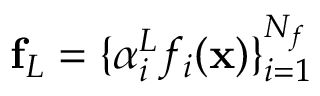<formula> <loc_0><loc_0><loc_500><loc_500>f _ { L } = \{ \alpha _ { i } ^ { L } f _ { i } ( x ) \} _ { i = 1 } ^ { N _ { f } }</formula> 